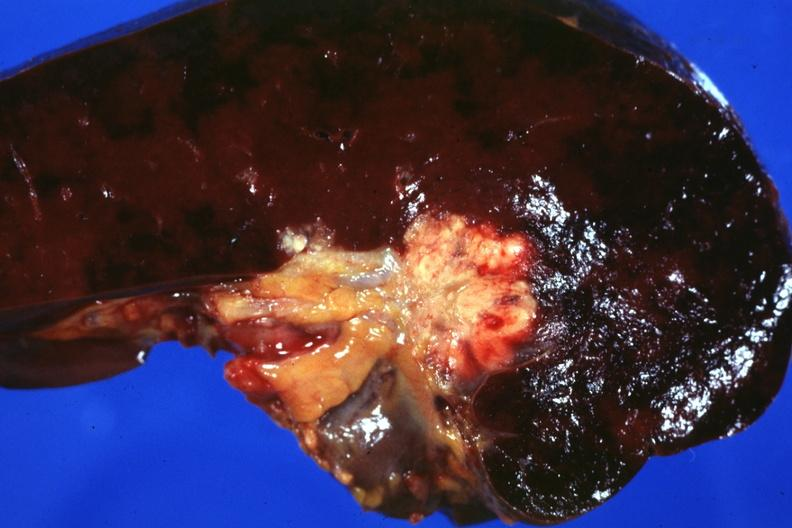what does this image show?
Answer the question using a single word or phrase. Section of spleen through hilum show tumor mass in hilum slide and large metastatic nodules in spleen 